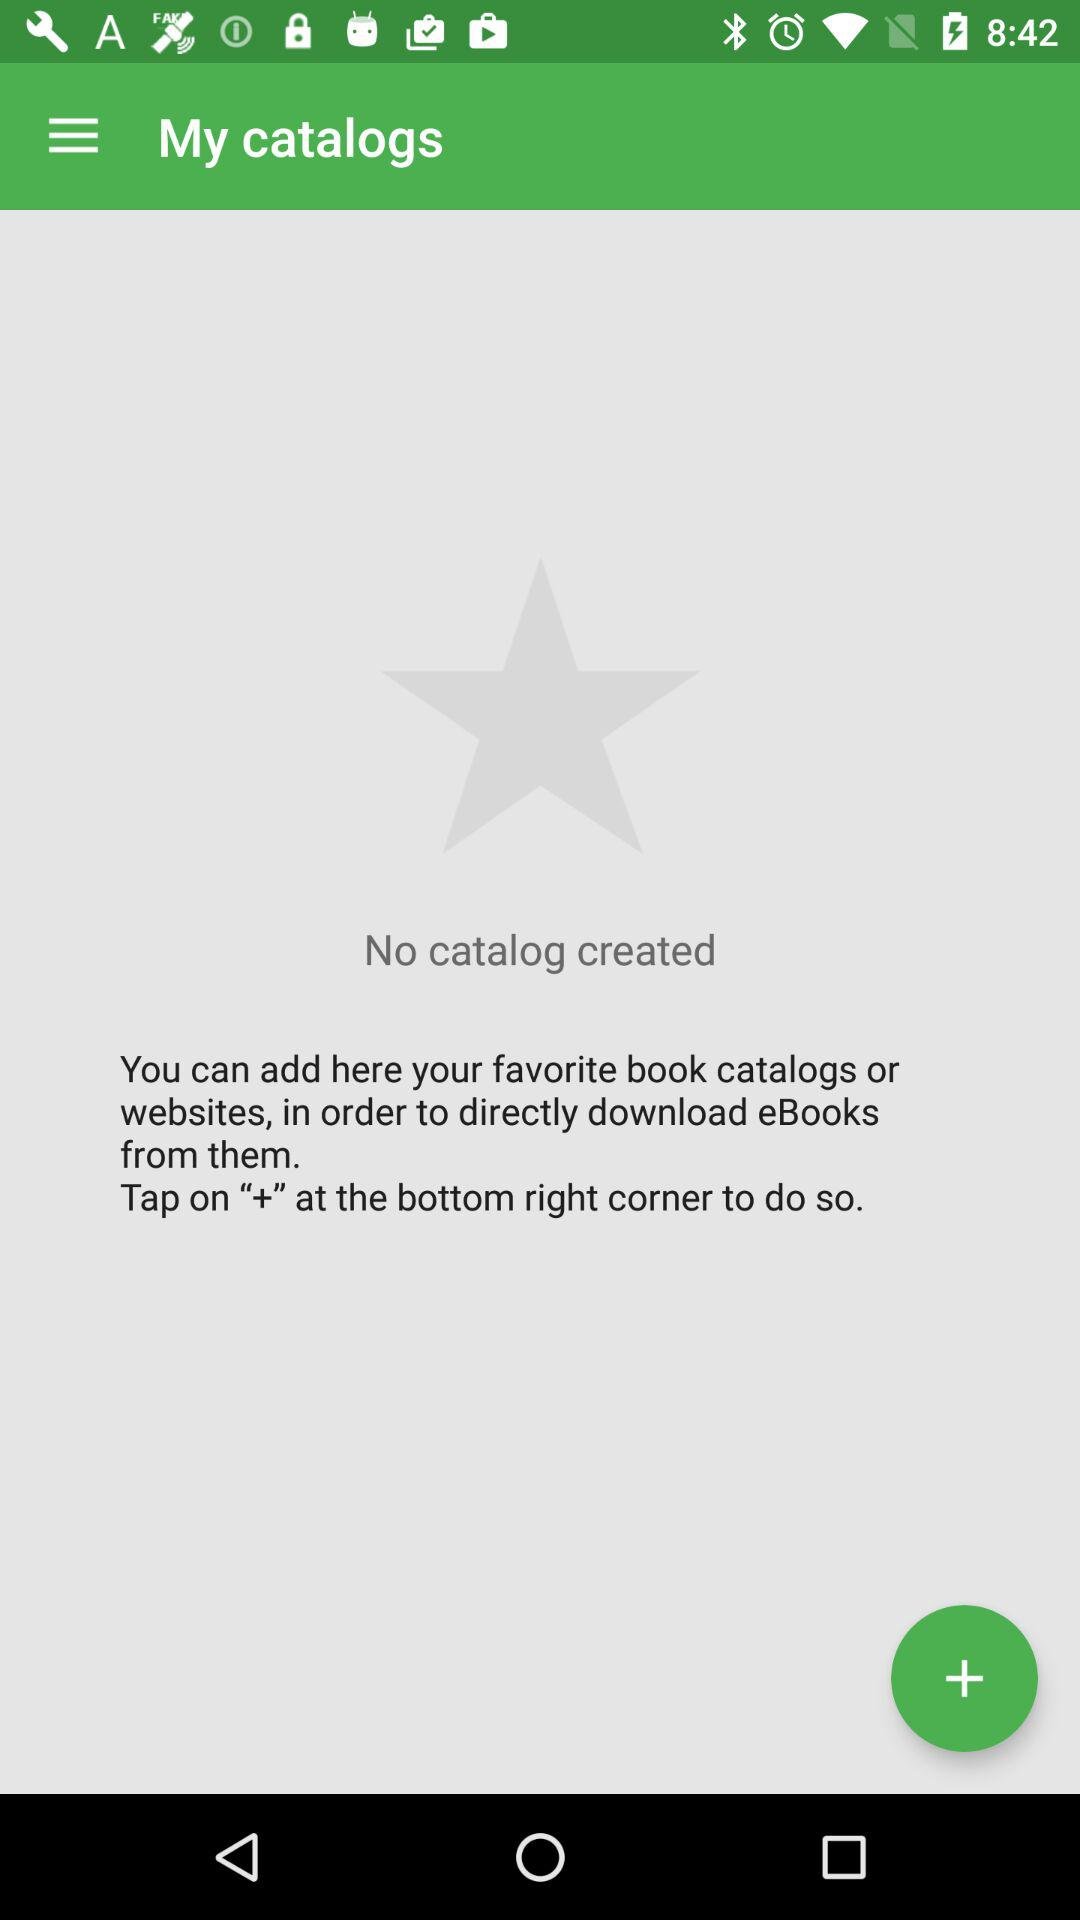How many catalogs are there?
Answer the question using a single word or phrase. 0 